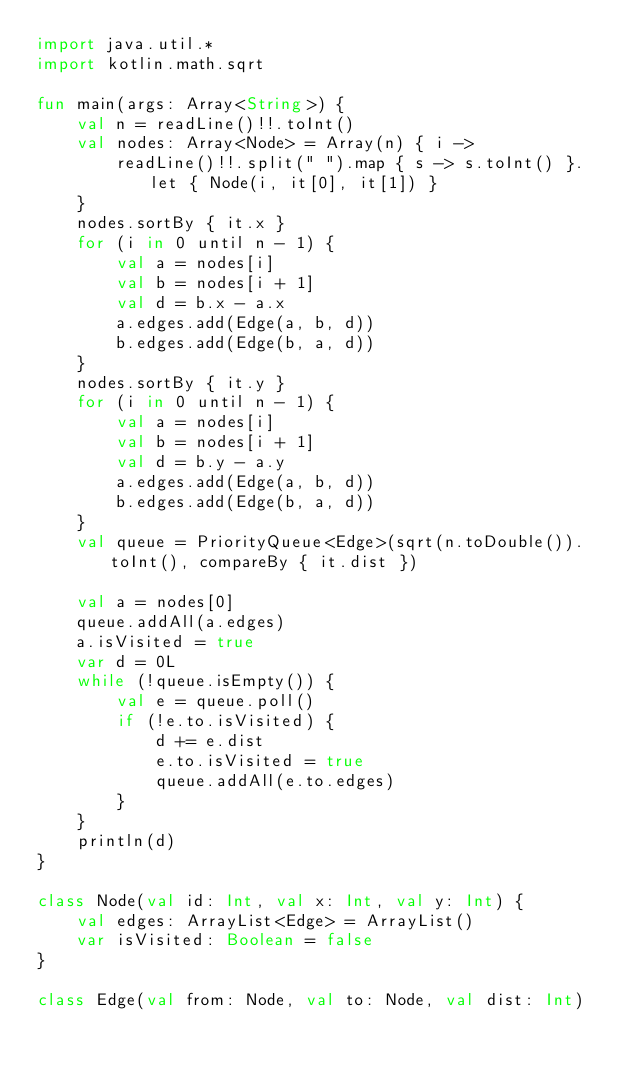<code> <loc_0><loc_0><loc_500><loc_500><_Kotlin_>import java.util.*
import kotlin.math.sqrt

fun main(args: Array<String>) {
    val n = readLine()!!.toInt()
    val nodes: Array<Node> = Array(n) { i ->
        readLine()!!.split(" ").map { s -> s.toInt() }.let { Node(i, it[0], it[1]) }
    }
    nodes.sortBy { it.x }
    for (i in 0 until n - 1) {
        val a = nodes[i]
        val b = nodes[i + 1]
        val d = b.x - a.x
        a.edges.add(Edge(a, b, d))
        b.edges.add(Edge(b, a, d))
    }
    nodes.sortBy { it.y }
    for (i in 0 until n - 1) {
        val a = nodes[i]
        val b = nodes[i + 1]
        val d = b.y - a.y
        a.edges.add(Edge(a, b, d))
        b.edges.add(Edge(b, a, d))
    }
    val queue = PriorityQueue<Edge>(sqrt(n.toDouble()).toInt(), compareBy { it.dist })

    val a = nodes[0]
    queue.addAll(a.edges)
    a.isVisited = true
    var d = 0L
    while (!queue.isEmpty()) {
        val e = queue.poll()
        if (!e.to.isVisited) {
            d += e.dist
            e.to.isVisited = true
            queue.addAll(e.to.edges)
        }
    }
    println(d)
}

class Node(val id: Int, val x: Int, val y: Int) {
    val edges: ArrayList<Edge> = ArrayList()
    var isVisited: Boolean = false
}

class Edge(val from: Node, val to: Node, val dist: Int)</code> 